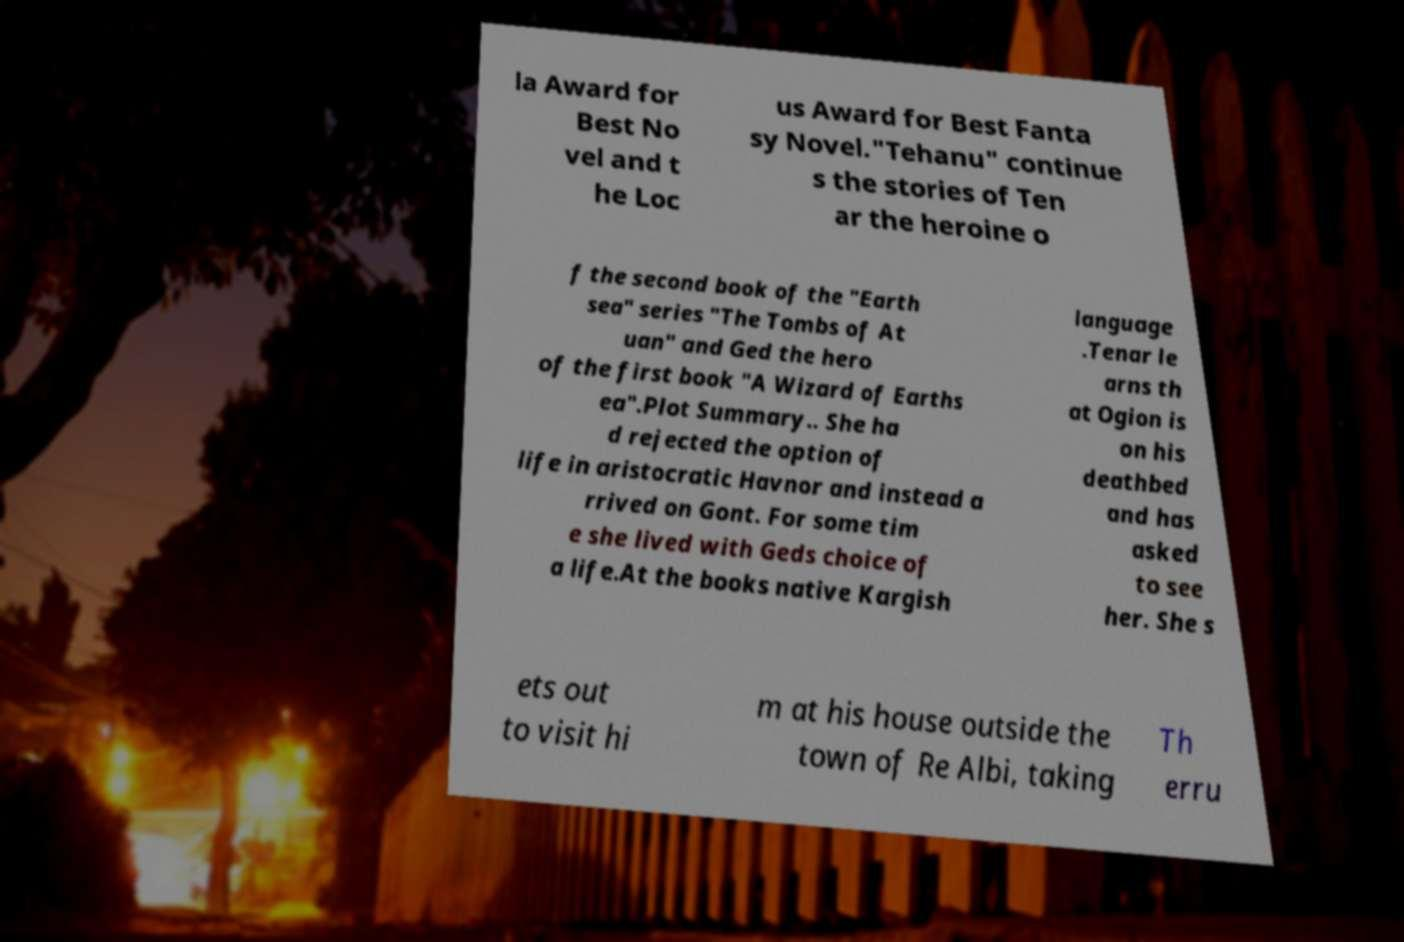Can you accurately transcribe the text from the provided image for me? la Award for Best No vel and t he Loc us Award for Best Fanta sy Novel."Tehanu" continue s the stories of Ten ar the heroine o f the second book of the "Earth sea" series "The Tombs of At uan" and Ged the hero of the first book "A Wizard of Earths ea".Plot Summary.. She ha d rejected the option of life in aristocratic Havnor and instead a rrived on Gont. For some tim e she lived with Geds choice of a life.At the books native Kargish language .Tenar le arns th at Ogion is on his deathbed and has asked to see her. She s ets out to visit hi m at his house outside the town of Re Albi, taking Th erru 